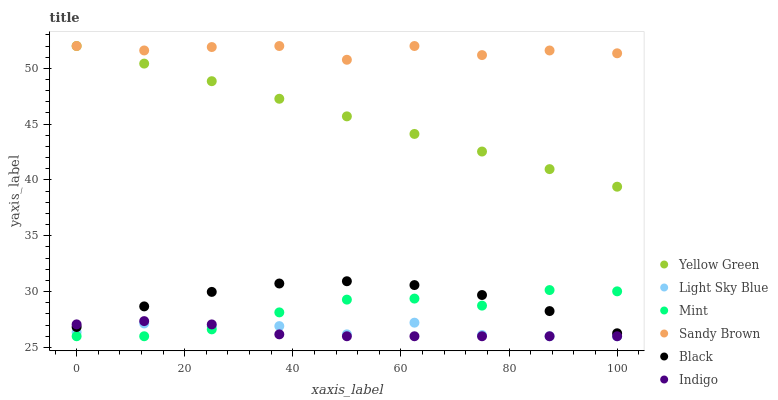Does Indigo have the minimum area under the curve?
Answer yes or no. Yes. Does Sandy Brown have the maximum area under the curve?
Answer yes or no. Yes. Does Yellow Green have the minimum area under the curve?
Answer yes or no. No. Does Yellow Green have the maximum area under the curve?
Answer yes or no. No. Is Yellow Green the smoothest?
Answer yes or no. Yes. Is Sandy Brown the roughest?
Answer yes or no. Yes. Is Mint the smoothest?
Answer yes or no. No. Is Mint the roughest?
Answer yes or no. No. Does Indigo have the lowest value?
Answer yes or no. Yes. Does Yellow Green have the lowest value?
Answer yes or no. No. Does Sandy Brown have the highest value?
Answer yes or no. Yes. Does Mint have the highest value?
Answer yes or no. No. Is Mint less than Sandy Brown?
Answer yes or no. Yes. Is Yellow Green greater than Mint?
Answer yes or no. Yes. Does Yellow Green intersect Sandy Brown?
Answer yes or no. Yes. Is Yellow Green less than Sandy Brown?
Answer yes or no. No. Is Yellow Green greater than Sandy Brown?
Answer yes or no. No. Does Mint intersect Sandy Brown?
Answer yes or no. No. 